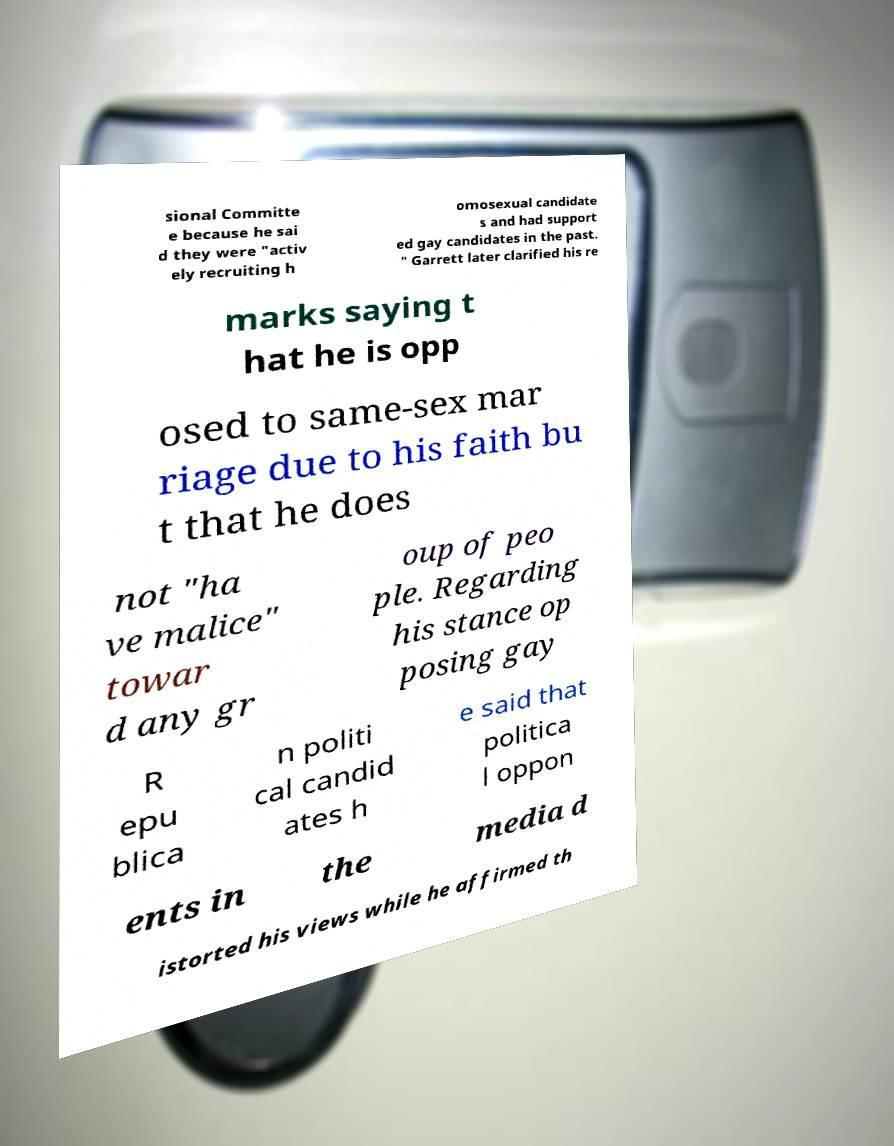Please read and relay the text visible in this image. What does it say? sional Committe e because he sai d they were "activ ely recruiting h omosexual candidate s and had support ed gay candidates in the past. " Garrett later clarified his re marks saying t hat he is opp osed to same-sex mar riage due to his faith bu t that he does not "ha ve malice" towar d any gr oup of peo ple. Regarding his stance op posing gay R epu blica n politi cal candid ates h e said that politica l oppon ents in the media d istorted his views while he affirmed th 